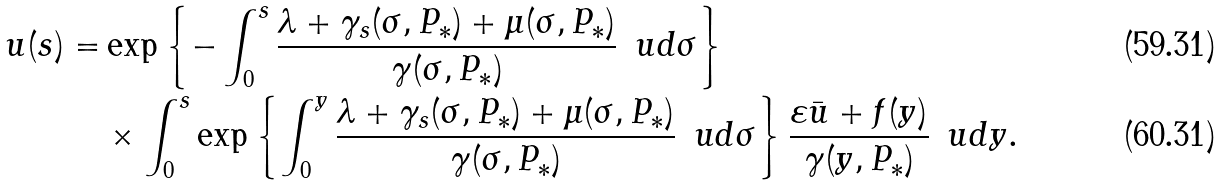Convert formula to latex. <formula><loc_0><loc_0><loc_500><loc_500>u ( s ) = & \exp \left \{ - \int _ { 0 } ^ { s } \frac { \lambda + \gamma _ { s } ( \sigma , P _ { * } ) + \mu ( \sigma , P _ { * } ) } { \gamma ( \sigma , P _ { * } ) } \, \ u d \sigma \right \} \\ & \times \int _ { 0 } ^ { s } \exp \left \{ \int _ { 0 } ^ { y } \frac { \lambda + \gamma _ { s } ( \sigma , P _ { * } ) + \mu ( \sigma , P _ { * } ) } { \gamma ( \sigma , P _ { * } ) } \, \ u d \sigma \right \} \frac { \varepsilon \bar { u } + f ( y ) } { \gamma ( y , P _ { * } ) } \, \ u d y .</formula> 